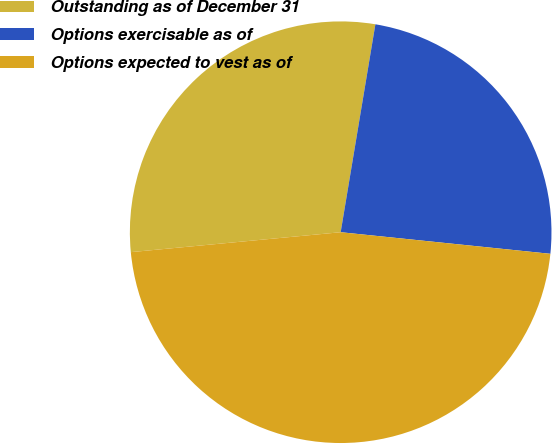Convert chart. <chart><loc_0><loc_0><loc_500><loc_500><pie_chart><fcel>Outstanding as of December 31<fcel>Options exercisable as of<fcel>Options expected to vest as of<nl><fcel>29.14%<fcel>24.0%<fcel>46.86%<nl></chart> 